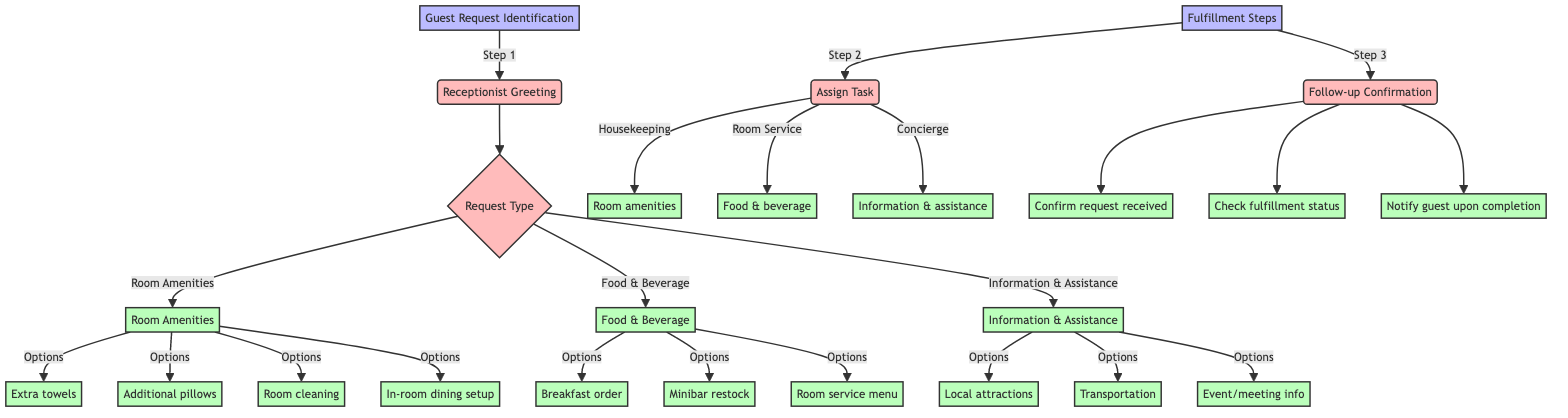What is the first step in the guest request identification process? The first step in the process is the receptionist greeting the guest and inquiring about their needs, as indicated in the diagram.
Answer: Receptionist Greeting How many types of requests does the diagram identify? The diagram identifies three types of requests: Room Amenities, Food & Beverage, and Information & Assistance.
Answer: Three Which department handles food and beverage requests? From the diagram, food and beverage requests are specifically handled by the Room Service department.
Answer: Room Service What should the receptionist confirm when handling room amenity requests? The receptionist should confirm the specific quantity or details needed for room amenity requests, as noted under Room Amenities in the diagram.
Answer: Quantity or details After assigning a request, what is the next step related to fulfillment? The diagram indicates that the next step is Follow-up Confirmation, which involves actions to ensure the guest is updated on their request status.
Answer: Follow-up Confirmation How many options are available under food and beverage requests? In the diagram, there are three options listed under Food & Beverage, namely Breakfast order, Minibar restock, and Room service menu.
Answer: Three Which option is available under Information Assistance? The diagram lists three options under Information Assistance, one of which is local attractions details.
Answer: Local attractions details What action should be taken after confirming the request is received? After confirming the request is received, the next action is to check on the status of the fulfillment, as specified in the Follow-up Confirmation step.
Answer: Check fulfillment status What is the primary function of the housekeeping department according to the diagram? The primary function of the housekeeping department, as indicated, is to handle requests for extra towels, additional pillows, and room cleaning.
Answer: Extra towels, additional pillows, room cleaning 